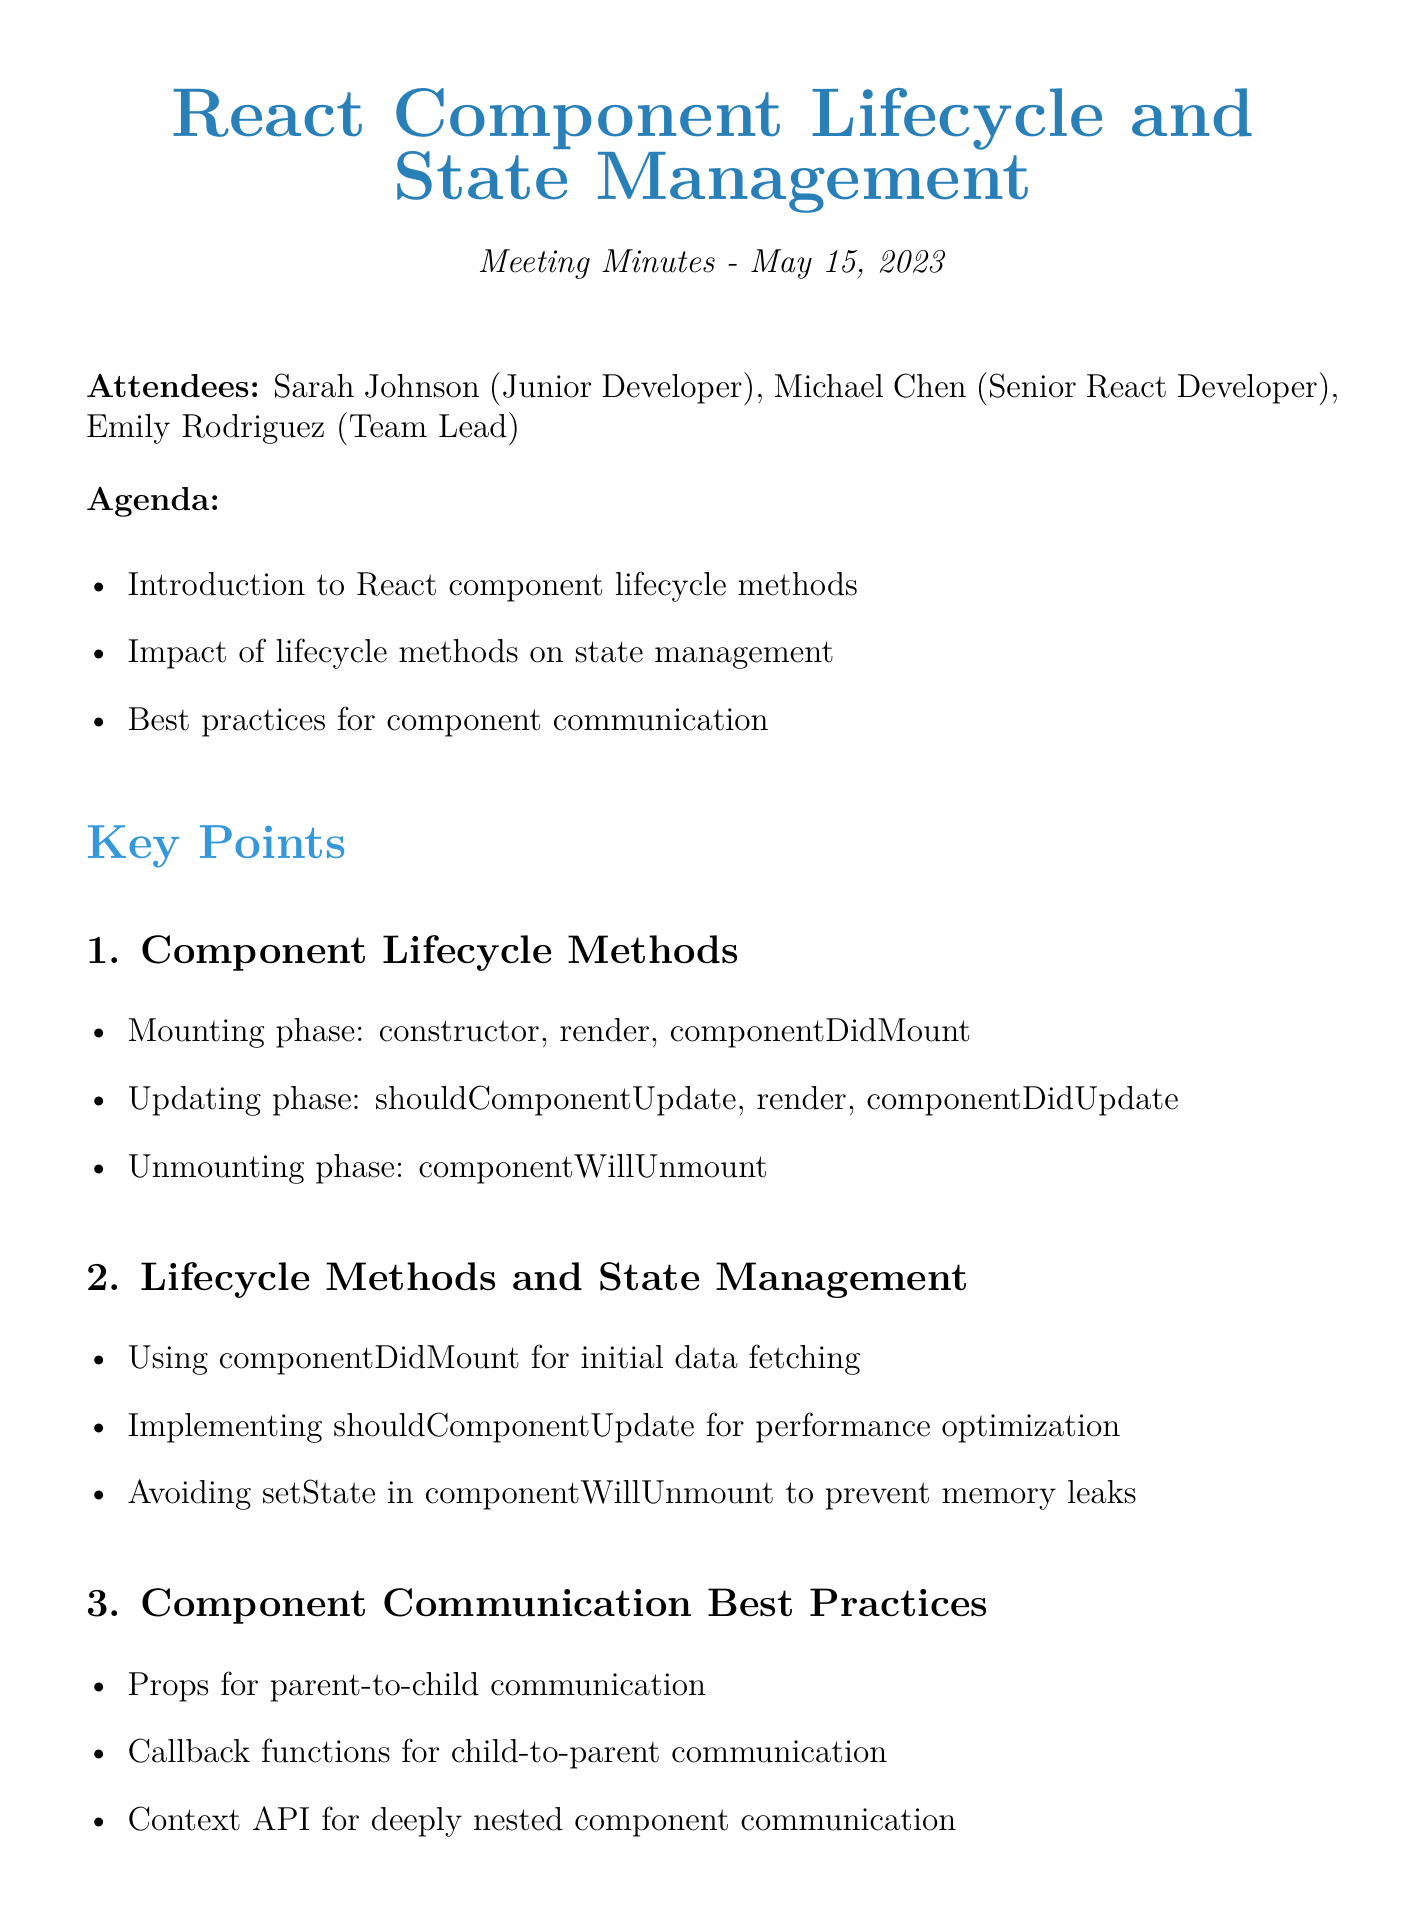What is the meeting date? The meeting date is listed in the document under "Meeting Minutes," stating May 15, 2023.
Answer: May 15, 2023 Who is the Team Lead? The document lists the attendees, indicating that Emily Rodriguez is the Team Lead.
Answer: Emily Rodriguez What is discussed in the first agenda item? The agenda item titles provide a clear summary, with the first item discussing React component lifecycle methods.
Answer: Introduction to React component lifecycle methods Which lifecycle method is mentioned for initial data fetching? The key points highlight that componentDidMount is used for initial data fetching within the lifecycle methods.
Answer: componentDidMount What is the main focus of the last key point? The last key point focuses on best practices for component communication, specifically regarding communication between components.
Answer: Component Communication Best Practices How many action items are listed in the document? The action items section enumerates the tasks assigned, which total three action items.
Answer: Three What resource is provided for official documentation? The resources section includes a URL to the official React documentation, outlining where to find it.
Answer: https://reactjs.org/docs/react-component.html Which method should be avoided to prevent memory leaks? The document states that setState should be avoided in componentWillUnmount to prevent memory leaks.
Answer: setState in componentWillUnmount 